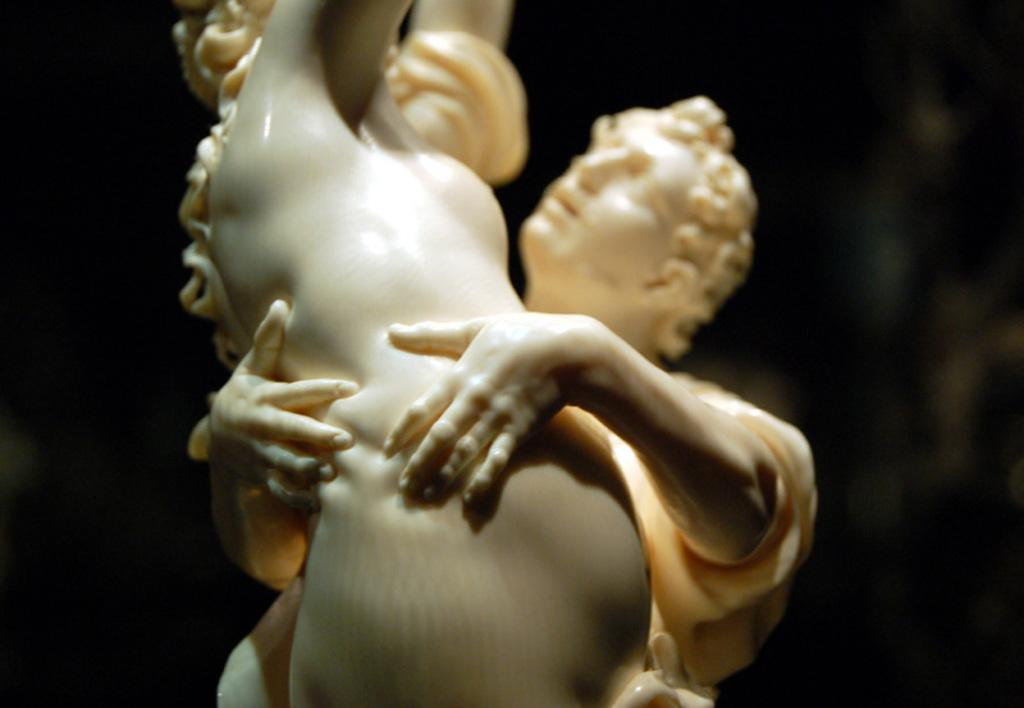What is the main subject of the image? The main subject of the image is a sculpture of two persons. What can be seen in the background of the image? The background of the image is black. What type of berry is being held by one of the persons in the sculpture? There is no berry present in the image; it is a sculpture of two persons without any additional objects. 